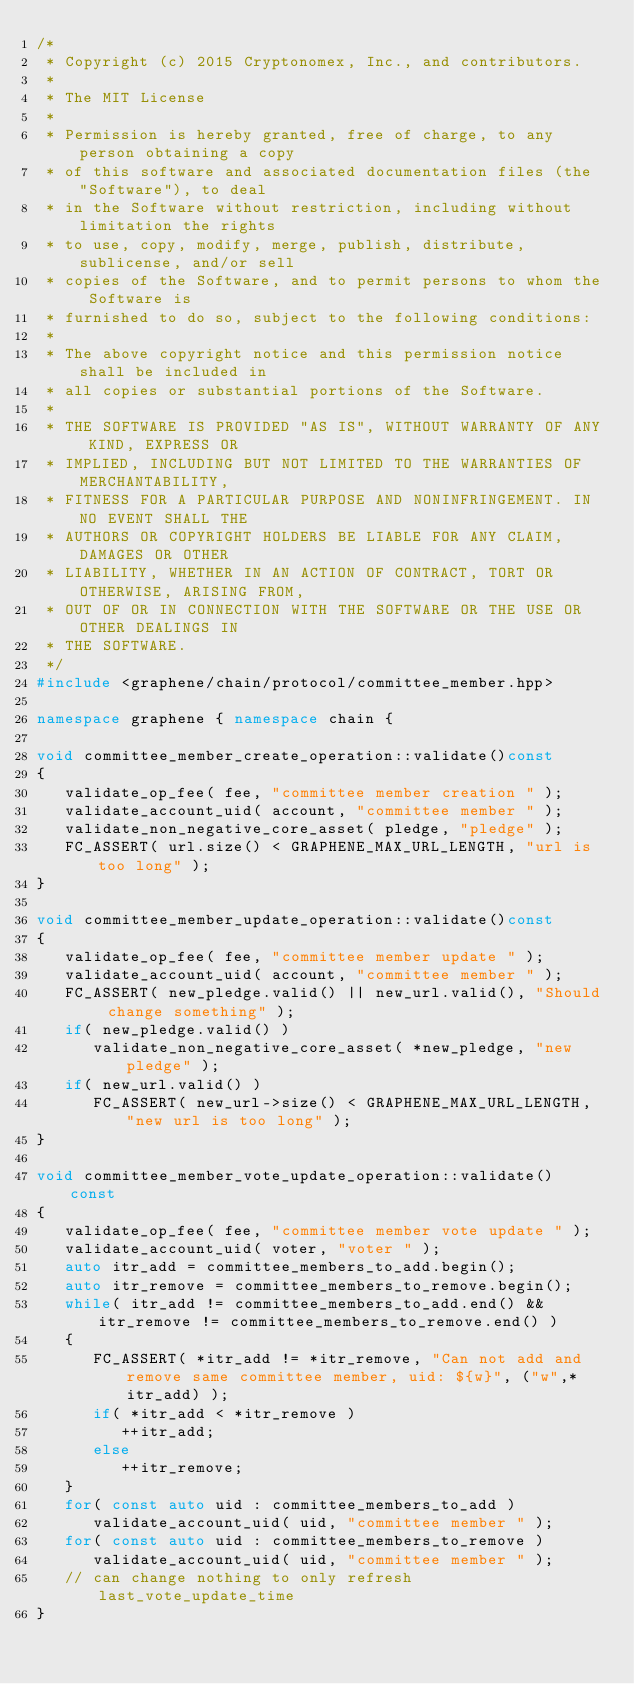<code> <loc_0><loc_0><loc_500><loc_500><_C++_>/*
 * Copyright (c) 2015 Cryptonomex, Inc., and contributors.
 *
 * The MIT License
 *
 * Permission is hereby granted, free of charge, to any person obtaining a copy
 * of this software and associated documentation files (the "Software"), to deal
 * in the Software without restriction, including without limitation the rights
 * to use, copy, modify, merge, publish, distribute, sublicense, and/or sell
 * copies of the Software, and to permit persons to whom the Software is
 * furnished to do so, subject to the following conditions:
 *
 * The above copyright notice and this permission notice shall be included in
 * all copies or substantial portions of the Software.
 *
 * THE SOFTWARE IS PROVIDED "AS IS", WITHOUT WARRANTY OF ANY KIND, EXPRESS OR
 * IMPLIED, INCLUDING BUT NOT LIMITED TO THE WARRANTIES OF MERCHANTABILITY,
 * FITNESS FOR A PARTICULAR PURPOSE AND NONINFRINGEMENT. IN NO EVENT SHALL THE
 * AUTHORS OR COPYRIGHT HOLDERS BE LIABLE FOR ANY CLAIM, DAMAGES OR OTHER
 * LIABILITY, WHETHER IN AN ACTION OF CONTRACT, TORT OR OTHERWISE, ARISING FROM,
 * OUT OF OR IN CONNECTION WITH THE SOFTWARE OR THE USE OR OTHER DEALINGS IN
 * THE SOFTWARE.
 */
#include <graphene/chain/protocol/committee_member.hpp>

namespace graphene { namespace chain {

void committee_member_create_operation::validate()const
{
   validate_op_fee( fee, "committee member creation " );
   validate_account_uid( account, "committee member " );
   validate_non_negative_core_asset( pledge, "pledge" );
   FC_ASSERT( url.size() < GRAPHENE_MAX_URL_LENGTH, "url is too long" );
}

void committee_member_update_operation::validate()const
{
   validate_op_fee( fee, "committee member update " );
   validate_account_uid( account, "committee member " );
   FC_ASSERT( new_pledge.valid() || new_url.valid(), "Should change something" );
   if( new_pledge.valid() )
      validate_non_negative_core_asset( *new_pledge, "new pledge" );
   if( new_url.valid() )
      FC_ASSERT( new_url->size() < GRAPHENE_MAX_URL_LENGTH, "new url is too long" );
}

void committee_member_vote_update_operation::validate() const
{
   validate_op_fee( fee, "committee member vote update " );
   validate_account_uid( voter, "voter " );
   auto itr_add = committee_members_to_add.begin();
   auto itr_remove = committee_members_to_remove.begin();
   while( itr_add != committee_members_to_add.end() && itr_remove != committee_members_to_remove.end() )
   {
      FC_ASSERT( *itr_add != *itr_remove, "Can not add and remove same committee member, uid: ${w}", ("w",*itr_add) );
      if( *itr_add < *itr_remove )
         ++itr_add;
      else
         ++itr_remove;
   }
   for( const auto uid : committee_members_to_add )
      validate_account_uid( uid, "committee member " );
   for( const auto uid : committee_members_to_remove )
      validate_account_uid( uid, "committee member " );
   // can change nothing to only refresh last_vote_update_time
}
</code> 